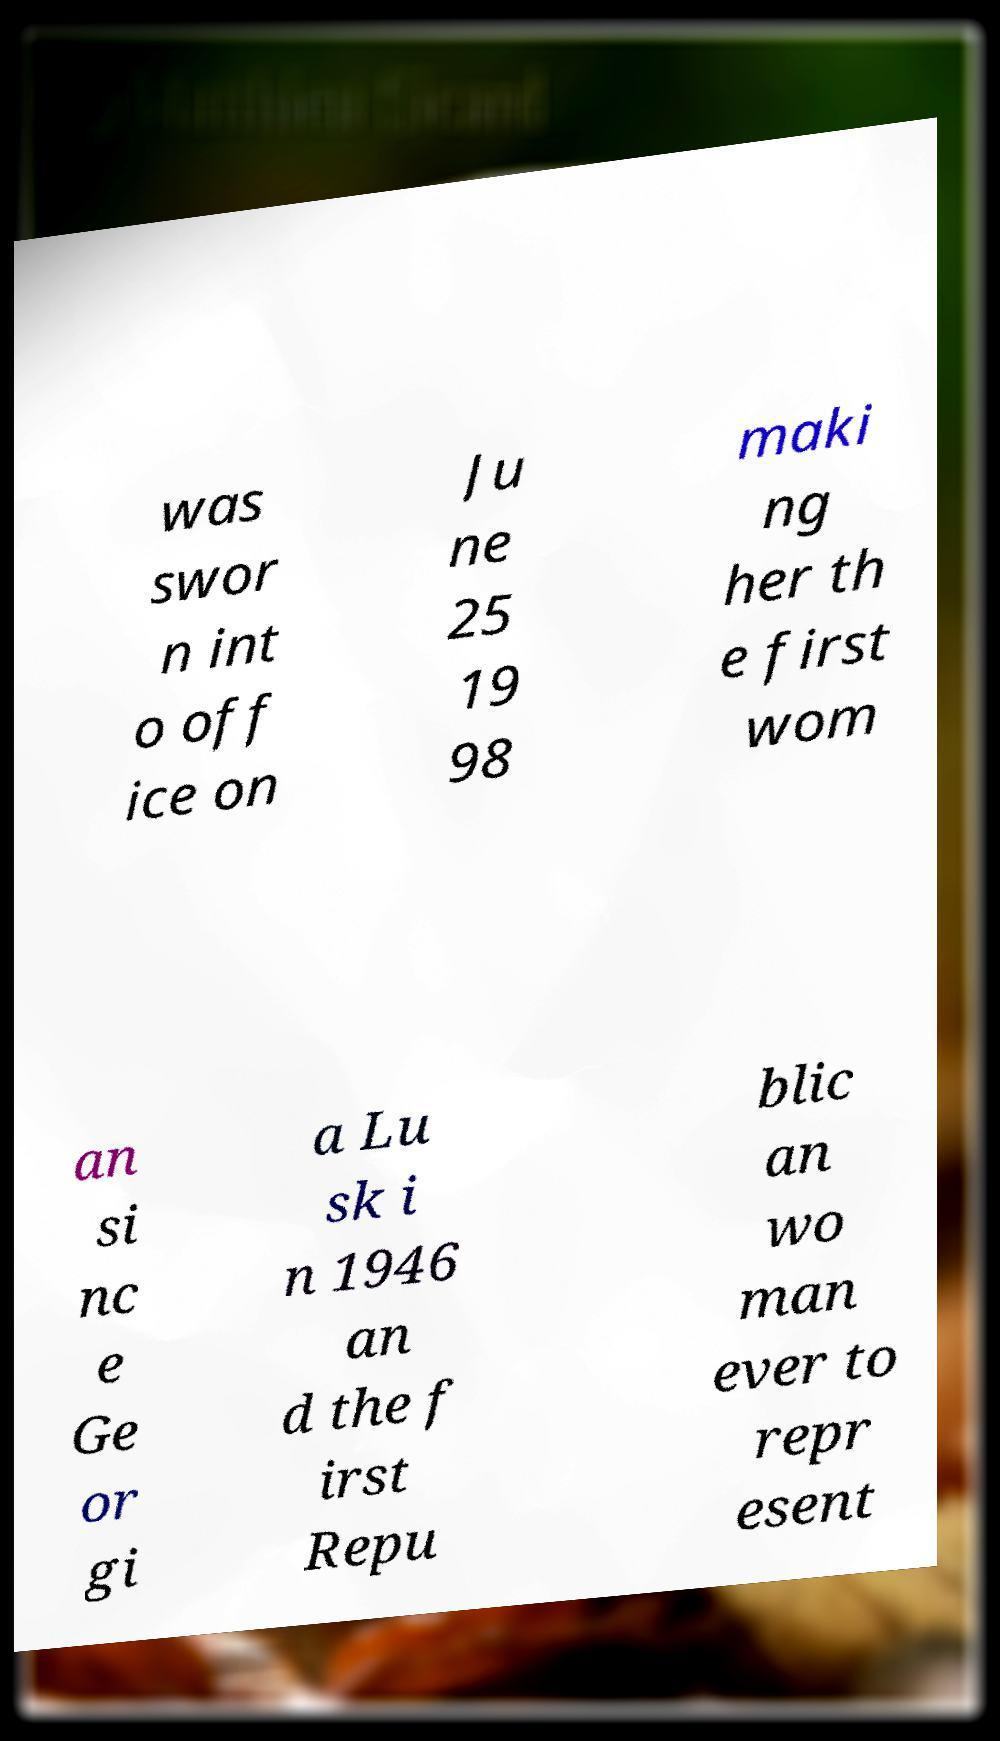Could you extract and type out the text from this image? was swor n int o off ice on Ju ne 25 19 98 maki ng her th e first wom an si nc e Ge or gi a Lu sk i n 1946 an d the f irst Repu blic an wo man ever to repr esent 